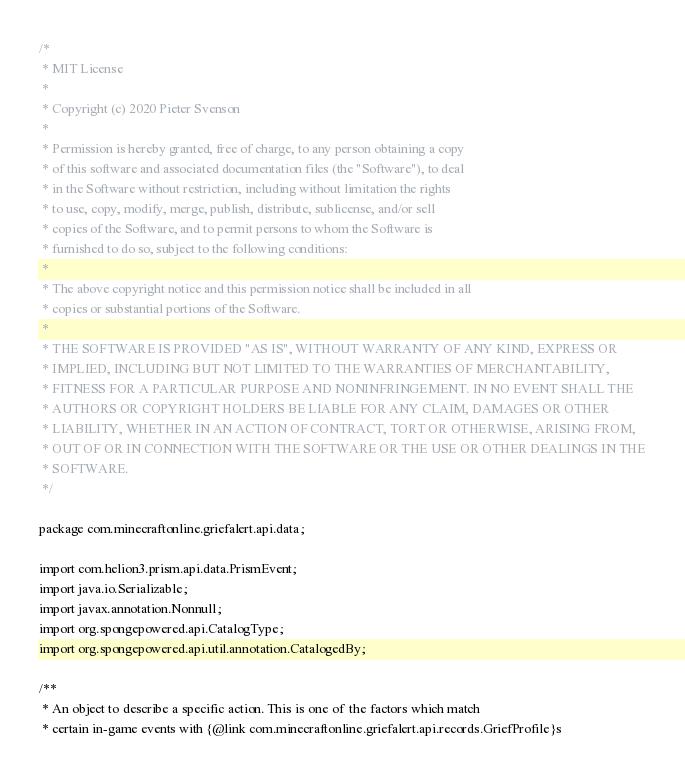Convert code to text. <code><loc_0><loc_0><loc_500><loc_500><_Java_>/*
 * MIT License
 *
 * Copyright (c) 2020 Pieter Svenson
 *
 * Permission is hereby granted, free of charge, to any person obtaining a copy
 * of this software and associated documentation files (the "Software"), to deal
 * in the Software without restriction, including without limitation the rights
 * to use, copy, modify, merge, publish, distribute, sublicense, and/or sell
 * copies of the Software, and to permit persons to whom the Software is
 * furnished to do so, subject to the following conditions:
 *
 * The above copyright notice and this permission notice shall be included in all
 * copies or substantial portions of the Software.
 *
 * THE SOFTWARE IS PROVIDED "AS IS", WITHOUT WARRANTY OF ANY KIND, EXPRESS OR
 * IMPLIED, INCLUDING BUT NOT LIMITED TO THE WARRANTIES OF MERCHANTABILITY,
 * FITNESS FOR A PARTICULAR PURPOSE AND NONINFRINGEMENT. IN NO EVENT SHALL THE
 * AUTHORS OR COPYRIGHT HOLDERS BE LIABLE FOR ANY CLAIM, DAMAGES OR OTHER
 * LIABILITY, WHETHER IN AN ACTION OF CONTRACT, TORT OR OTHERWISE, ARISING FROM,
 * OUT OF OR IN CONNECTION WITH THE SOFTWARE OR THE USE OR OTHER DEALINGS IN THE
 * SOFTWARE.
 */

package com.minecraftonline.griefalert.api.data;

import com.helion3.prism.api.data.PrismEvent;
import java.io.Serializable;
import javax.annotation.Nonnull;
import org.spongepowered.api.CatalogType;
import org.spongepowered.api.util.annotation.CatalogedBy;

/**
 * An object to describe a specific action. This is one of the factors which match
 * certain in-game events with {@link com.minecraftonline.griefalert.api.records.GriefProfile}s</code> 